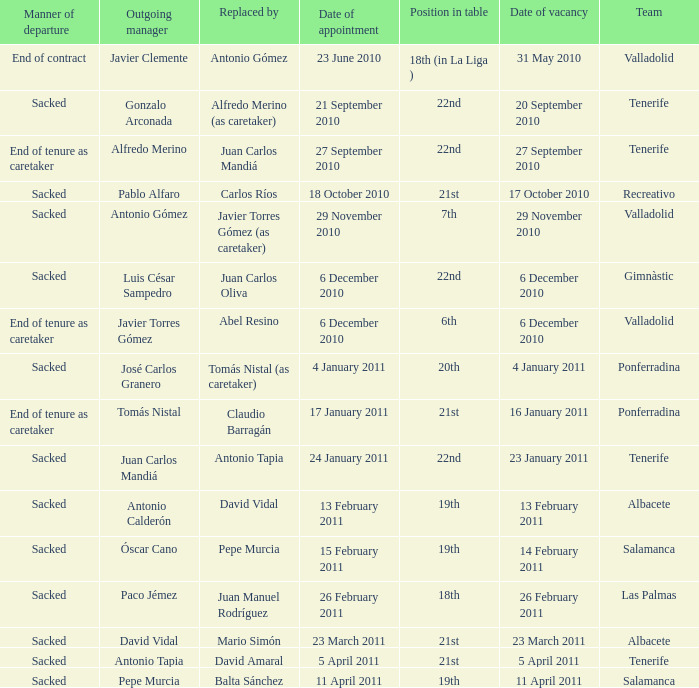What was the position of appointment date 17 january 2011 21st. 